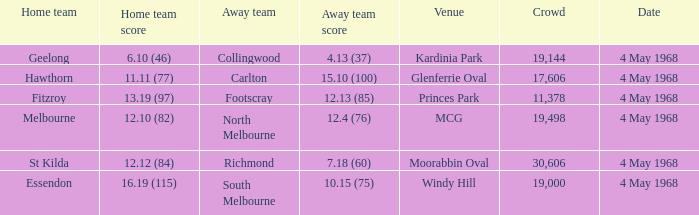How big was the crowd of the team that scored 4.13 (37)? 19144.0. 